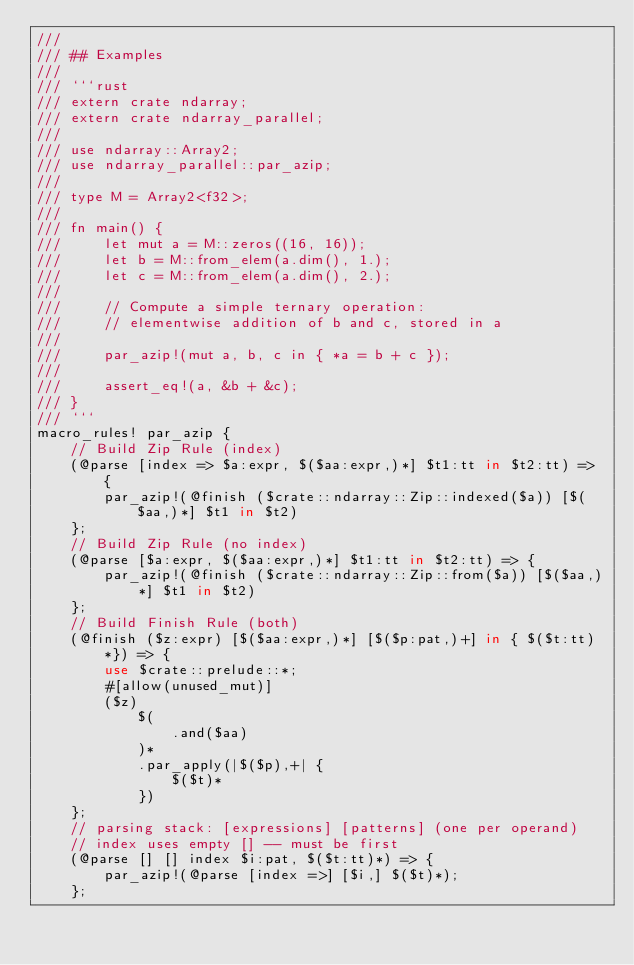<code> <loc_0><loc_0><loc_500><loc_500><_Rust_>///
/// ## Examples
///
/// ```rust
/// extern crate ndarray;
/// extern crate ndarray_parallel;
///
/// use ndarray::Array2;
/// use ndarray_parallel::par_azip;
///
/// type M = Array2<f32>;
///
/// fn main() {
///     let mut a = M::zeros((16, 16));
///     let b = M::from_elem(a.dim(), 1.);
///     let c = M::from_elem(a.dim(), 2.);
///
///     // Compute a simple ternary operation:
///     // elementwise addition of b and c, stored in a
///
///     par_azip!(mut a, b, c in { *a = b + c });
///
///     assert_eq!(a, &b + &c);
/// }
/// ```
macro_rules! par_azip {
    // Build Zip Rule (index)
    (@parse [index => $a:expr, $($aa:expr,)*] $t1:tt in $t2:tt) => {
        par_azip!(@finish ($crate::ndarray::Zip::indexed($a)) [$($aa,)*] $t1 in $t2)
    };
    // Build Zip Rule (no index)
    (@parse [$a:expr, $($aa:expr,)*] $t1:tt in $t2:tt) => {
        par_azip!(@finish ($crate::ndarray::Zip::from($a)) [$($aa,)*] $t1 in $t2)
    };
    // Build Finish Rule (both)
    (@finish ($z:expr) [$($aa:expr,)*] [$($p:pat,)+] in { $($t:tt)*}) => {
        use $crate::prelude::*;
        #[allow(unused_mut)]
        ($z)
            $(
                .and($aa)
            )*
            .par_apply(|$($p),+| {
                $($t)*
            })
    };
    // parsing stack: [expressions] [patterns] (one per operand)
    // index uses empty [] -- must be first
    (@parse [] [] index $i:pat, $($t:tt)*) => {
        par_azip!(@parse [index =>] [$i,] $($t)*);
    };</code> 